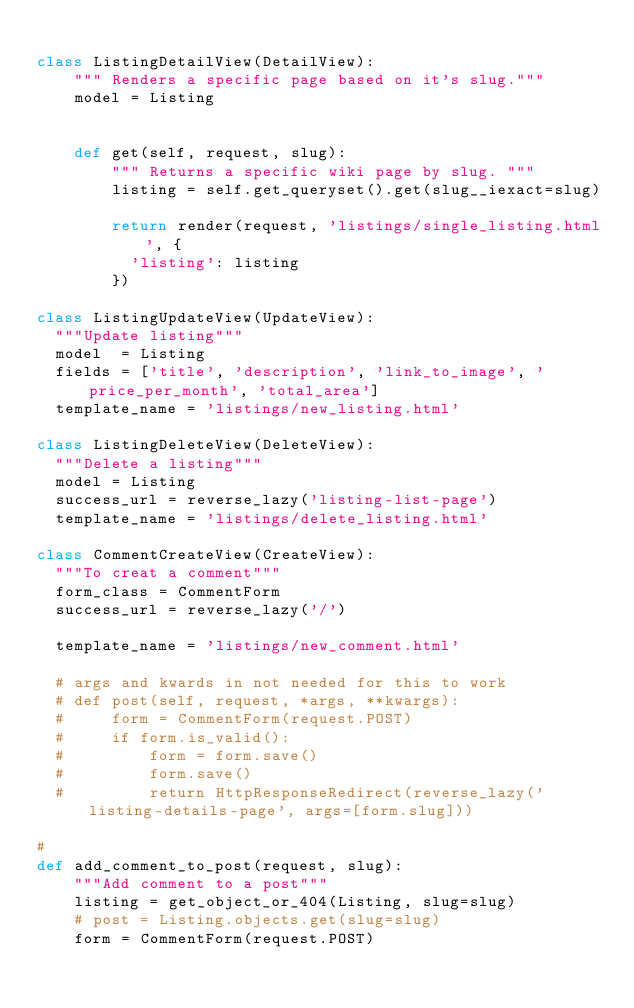<code> <loc_0><loc_0><loc_500><loc_500><_Python_>
class ListingDetailView(DetailView):
    """ Renders a specific page based on it's slug."""
    model = Listing


    def get(self, request, slug):
        """ Returns a specific wiki page by slug. """
        listing = self.get_queryset().get(slug__iexact=slug)

        return render(request, 'listings/single_listing.html', {
          'listing': listing
        })

class ListingUpdateView(UpdateView):
  """Update listing"""
  model  = Listing
  fields = ['title', 'description', 'link_to_image', 'price_per_month', 'total_area']
  template_name = 'listings/new_listing.html'

class ListingDeleteView(DeleteView):
  """Delete a listing"""
  model = Listing
  success_url = reverse_lazy('listing-list-page')
  template_name = 'listings/delete_listing.html'

class CommentCreateView(CreateView):
  """To creat a comment"""
  form_class = CommentForm
  success_url = reverse_lazy('/')

  template_name = 'listings/new_comment.html'

  # args and kwards in not needed for this to work
  # def post(self, request, *args, **kwargs):
  #     form = CommentForm(request.POST)
  #     if form.is_valid():
  #         form = form.save()
  #         form.save()
  #         return HttpResponseRedirect(reverse_lazy('listing-details-page', args=[form.slug]))

# 
def add_comment_to_post(request, slug):
    """Add comment to a post"""
    listing = get_object_or_404(Listing, slug=slug)
    # post = Listing.objects.get(slug=slug)
    form = CommentForm(request.POST)
</code> 